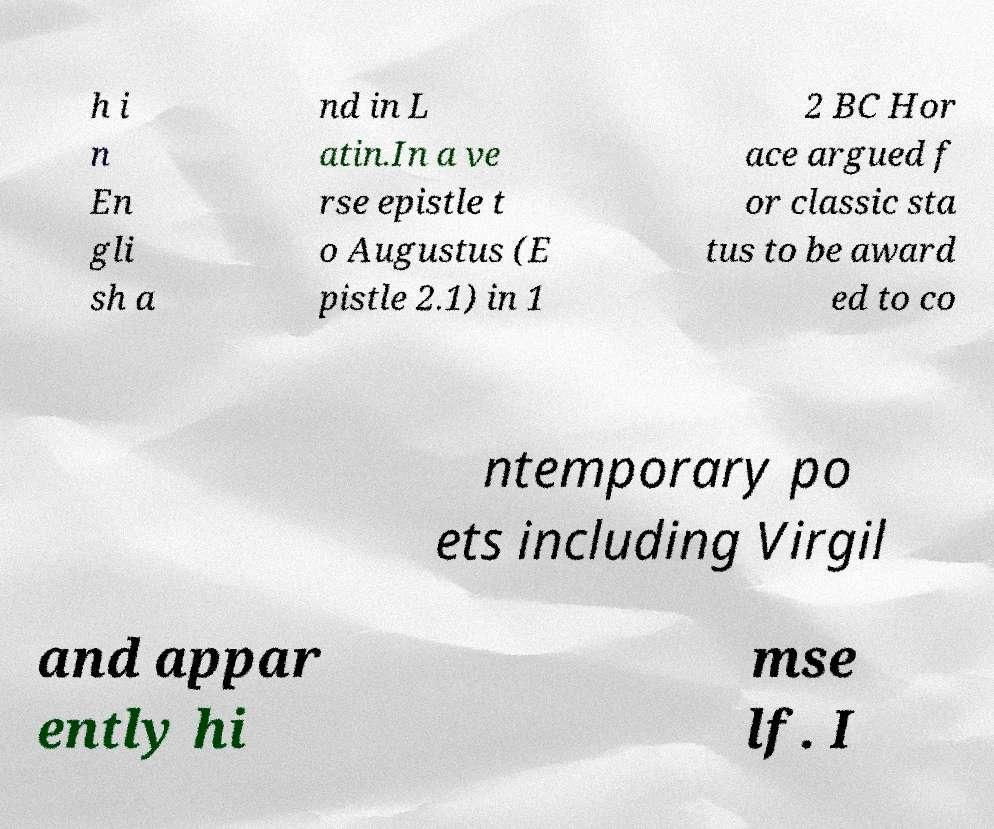Please read and relay the text visible in this image. What does it say? h i n En gli sh a nd in L atin.In a ve rse epistle t o Augustus (E pistle 2.1) in 1 2 BC Hor ace argued f or classic sta tus to be award ed to co ntemporary po ets including Virgil and appar ently hi mse lf. I 